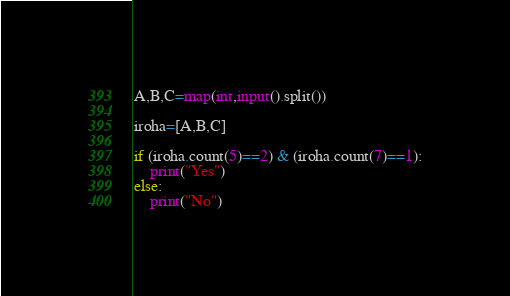<code> <loc_0><loc_0><loc_500><loc_500><_Python_>A,B,C=map(int,input().split())

iroha=[A,B,C]

if (iroha.count(5)==2) & (iroha.count(7)==1):
    print("Yes")
else:
    print("No")</code> 